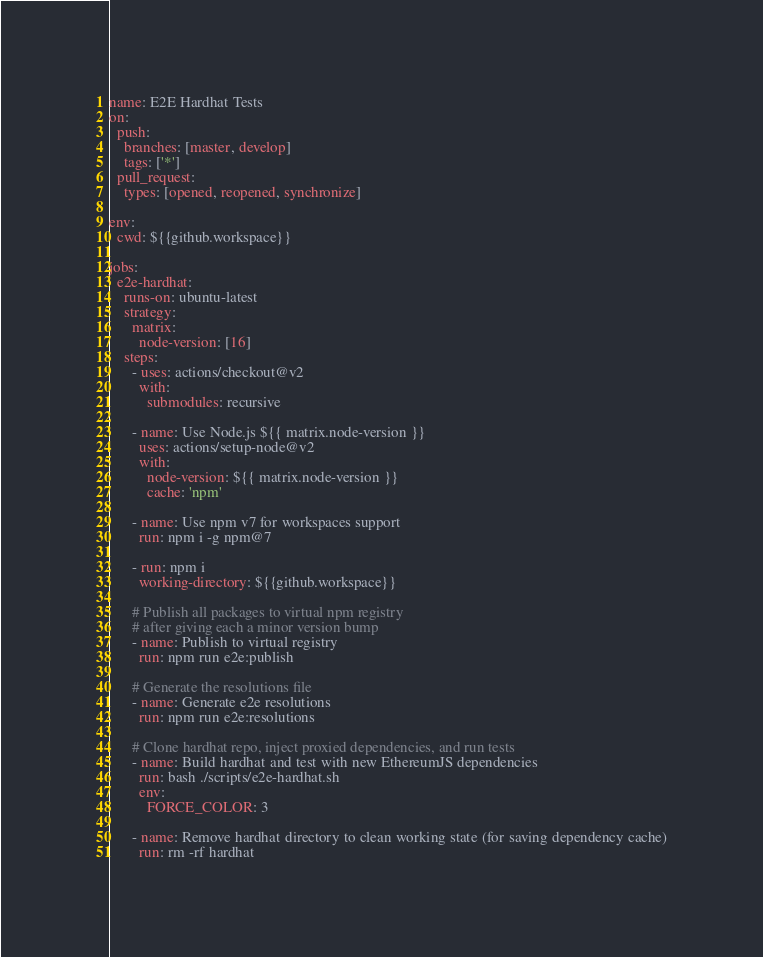<code> <loc_0><loc_0><loc_500><loc_500><_YAML_>name: E2E Hardhat Tests
on:
  push:
    branches: [master, develop]
    tags: ['*']
  pull_request:
    types: [opened, reopened, synchronize]
    
env:
  cwd: ${{github.workspace}}

jobs:
  e2e-hardhat:
    runs-on: ubuntu-latest
    strategy:
      matrix:
        node-version: [16]
    steps:
      - uses: actions/checkout@v2
        with:
          submodules: recursive

      - name: Use Node.js ${{ matrix.node-version }}
        uses: actions/setup-node@v2
        with:
          node-version: ${{ matrix.node-version }}
          cache: 'npm'

      - name: Use npm v7 for workspaces support 
        run: npm i -g npm@7

      - run: npm i
        working-directory: ${{github.workspace}}

      # Publish all packages to virtual npm registry
      # after giving each a minor version bump
      - name: Publish to virtual registry
        run: npm run e2e:publish

      # Generate the resolutions file
      - name: Generate e2e resolutions
        run: npm run e2e:resolutions

      # Clone hardhat repo, inject proxied dependencies, and run tests
      - name: Build hardhat and test with new EthereumJS dependencies
        run: bash ./scripts/e2e-hardhat.sh
        env:
          FORCE_COLOR: 3

      - name: Remove hardhat directory to clean working state (for saving dependency cache)
        run: rm -rf hardhat
</code> 